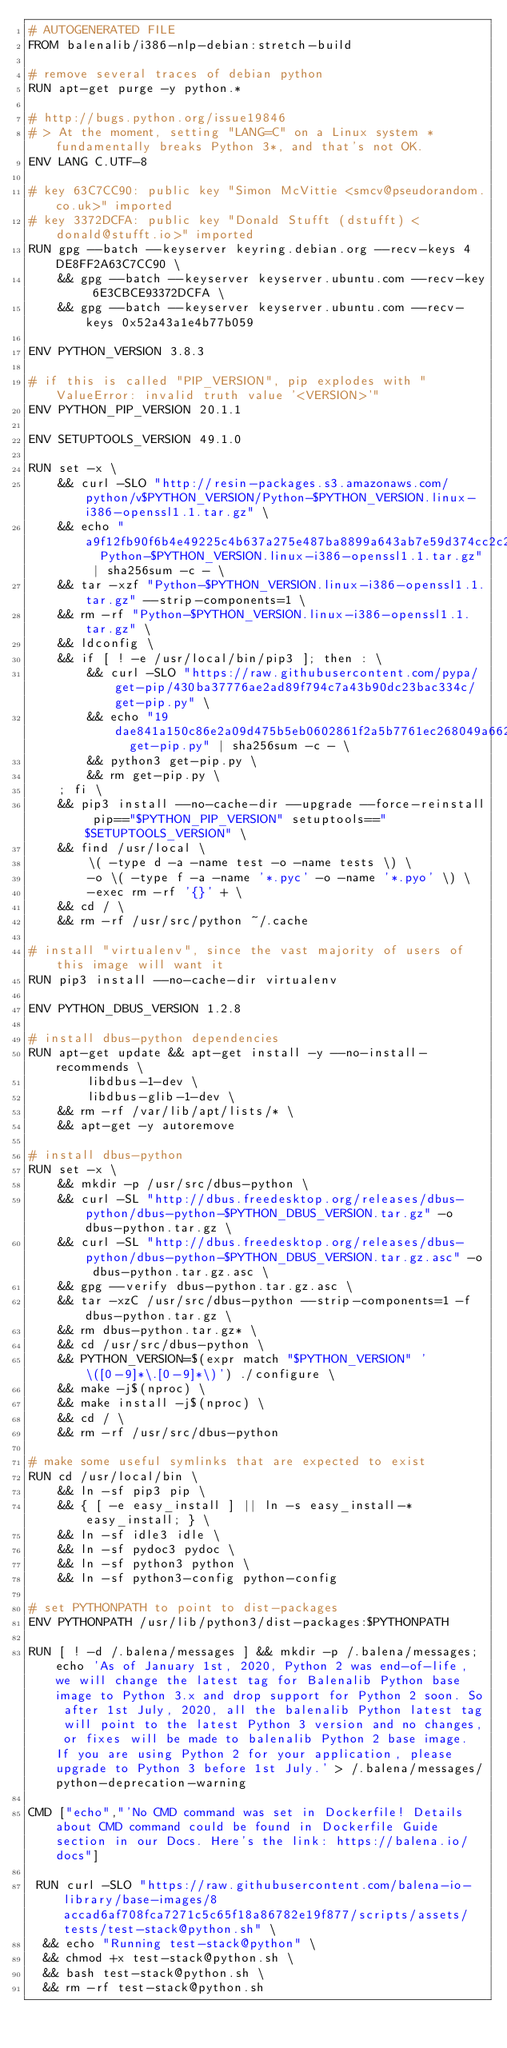Convert code to text. <code><loc_0><loc_0><loc_500><loc_500><_Dockerfile_># AUTOGENERATED FILE
FROM balenalib/i386-nlp-debian:stretch-build

# remove several traces of debian python
RUN apt-get purge -y python.*

# http://bugs.python.org/issue19846
# > At the moment, setting "LANG=C" on a Linux system *fundamentally breaks Python 3*, and that's not OK.
ENV LANG C.UTF-8

# key 63C7CC90: public key "Simon McVittie <smcv@pseudorandom.co.uk>" imported
# key 3372DCFA: public key "Donald Stufft (dstufft) <donald@stufft.io>" imported
RUN gpg --batch --keyserver keyring.debian.org --recv-keys 4DE8FF2A63C7CC90 \
	&& gpg --batch --keyserver keyserver.ubuntu.com --recv-key 6E3CBCE93372DCFA \
	&& gpg --batch --keyserver keyserver.ubuntu.com --recv-keys 0x52a43a1e4b77b059

ENV PYTHON_VERSION 3.8.3

# if this is called "PIP_VERSION", pip explodes with "ValueError: invalid truth value '<VERSION>'"
ENV PYTHON_PIP_VERSION 20.1.1

ENV SETUPTOOLS_VERSION 49.1.0

RUN set -x \
	&& curl -SLO "http://resin-packages.s3.amazonaws.com/python/v$PYTHON_VERSION/Python-$PYTHON_VERSION.linux-i386-openssl1.1.tar.gz" \
	&& echo "a9f12fb90f6b4e49225c4b637a275e487ba8899a643ab7e59d374cc2c25032d2  Python-$PYTHON_VERSION.linux-i386-openssl1.1.tar.gz" | sha256sum -c - \
	&& tar -xzf "Python-$PYTHON_VERSION.linux-i386-openssl1.1.tar.gz" --strip-components=1 \
	&& rm -rf "Python-$PYTHON_VERSION.linux-i386-openssl1.1.tar.gz" \
	&& ldconfig \
	&& if [ ! -e /usr/local/bin/pip3 ]; then : \
		&& curl -SLO "https://raw.githubusercontent.com/pypa/get-pip/430ba37776ae2ad89f794c7a43b90dc23bac334c/get-pip.py" \
		&& echo "19dae841a150c86e2a09d475b5eb0602861f2a5b7761ec268049a662dbd2bd0c  get-pip.py" | sha256sum -c - \
		&& python3 get-pip.py \
		&& rm get-pip.py \
	; fi \
	&& pip3 install --no-cache-dir --upgrade --force-reinstall pip=="$PYTHON_PIP_VERSION" setuptools=="$SETUPTOOLS_VERSION" \
	&& find /usr/local \
		\( -type d -a -name test -o -name tests \) \
		-o \( -type f -a -name '*.pyc' -o -name '*.pyo' \) \
		-exec rm -rf '{}' + \
	&& cd / \
	&& rm -rf /usr/src/python ~/.cache

# install "virtualenv", since the vast majority of users of this image will want it
RUN pip3 install --no-cache-dir virtualenv

ENV PYTHON_DBUS_VERSION 1.2.8

# install dbus-python dependencies 
RUN apt-get update && apt-get install -y --no-install-recommends \
		libdbus-1-dev \
		libdbus-glib-1-dev \
	&& rm -rf /var/lib/apt/lists/* \
	&& apt-get -y autoremove

# install dbus-python
RUN set -x \
	&& mkdir -p /usr/src/dbus-python \
	&& curl -SL "http://dbus.freedesktop.org/releases/dbus-python/dbus-python-$PYTHON_DBUS_VERSION.tar.gz" -o dbus-python.tar.gz \
	&& curl -SL "http://dbus.freedesktop.org/releases/dbus-python/dbus-python-$PYTHON_DBUS_VERSION.tar.gz.asc" -o dbus-python.tar.gz.asc \
	&& gpg --verify dbus-python.tar.gz.asc \
	&& tar -xzC /usr/src/dbus-python --strip-components=1 -f dbus-python.tar.gz \
	&& rm dbus-python.tar.gz* \
	&& cd /usr/src/dbus-python \
	&& PYTHON_VERSION=$(expr match "$PYTHON_VERSION" '\([0-9]*\.[0-9]*\)') ./configure \
	&& make -j$(nproc) \
	&& make install -j$(nproc) \
	&& cd / \
	&& rm -rf /usr/src/dbus-python

# make some useful symlinks that are expected to exist
RUN cd /usr/local/bin \
	&& ln -sf pip3 pip \
	&& { [ -e easy_install ] || ln -s easy_install-* easy_install; } \
	&& ln -sf idle3 idle \
	&& ln -sf pydoc3 pydoc \
	&& ln -sf python3 python \
	&& ln -sf python3-config python-config

# set PYTHONPATH to point to dist-packages
ENV PYTHONPATH /usr/lib/python3/dist-packages:$PYTHONPATH

RUN [ ! -d /.balena/messages ] && mkdir -p /.balena/messages; echo 'As of January 1st, 2020, Python 2 was end-of-life, we will change the latest tag for Balenalib Python base image to Python 3.x and drop support for Python 2 soon. So after 1st July, 2020, all the balenalib Python latest tag will point to the latest Python 3 version and no changes, or fixes will be made to balenalib Python 2 base image. If you are using Python 2 for your application, please upgrade to Python 3 before 1st July.' > /.balena/messages/python-deprecation-warning

CMD ["echo","'No CMD command was set in Dockerfile! Details about CMD command could be found in Dockerfile Guide section in our Docs. Here's the link: https://balena.io/docs"]

 RUN curl -SLO "https://raw.githubusercontent.com/balena-io-library/base-images/8accad6af708fca7271c5c65f18a86782e19f877/scripts/assets/tests/test-stack@python.sh" \
  && echo "Running test-stack@python" \
  && chmod +x test-stack@python.sh \
  && bash test-stack@python.sh \
  && rm -rf test-stack@python.sh 
</code> 